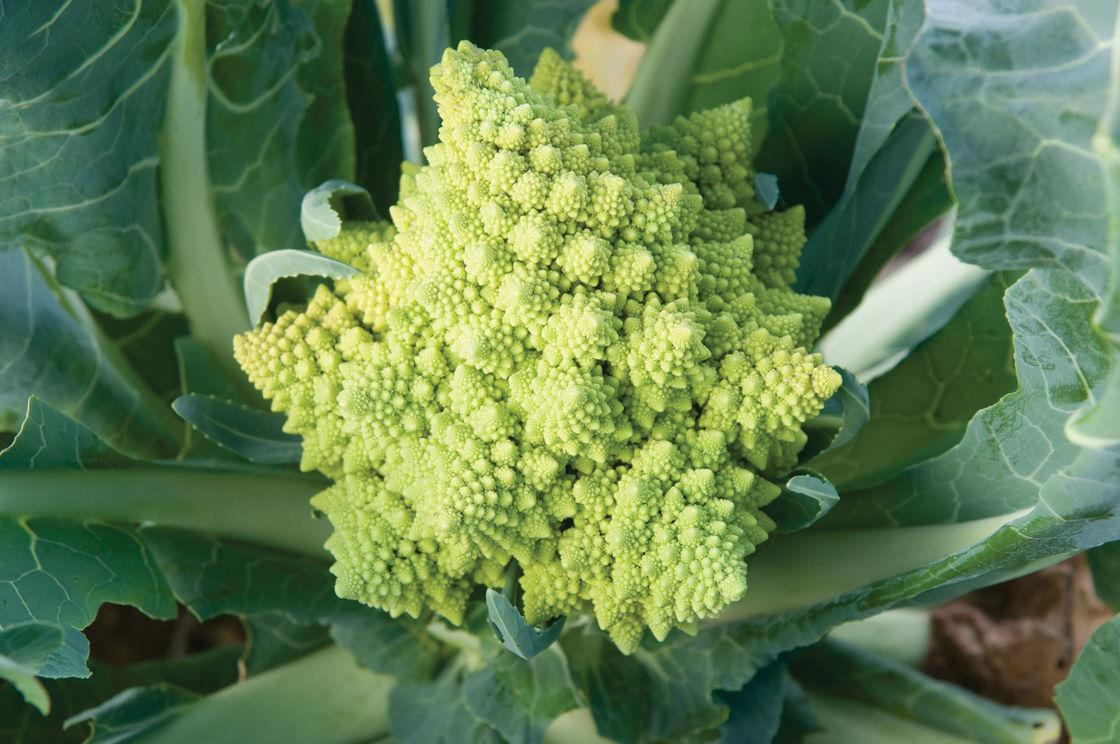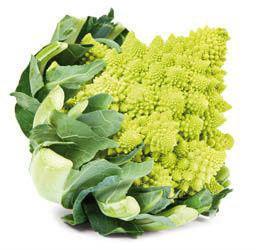The first image is the image on the left, the second image is the image on the right. Given the left and right images, does the statement "A full, uncut plant is seen in the image to the left." hold true? Answer yes or no. Yes. The first image is the image on the left, the second image is the image on the right. Evaluate the accuracy of this statement regarding the images: "The left and right image contains the same number of romanesco broccoli.". Is it true? Answer yes or no. Yes. 